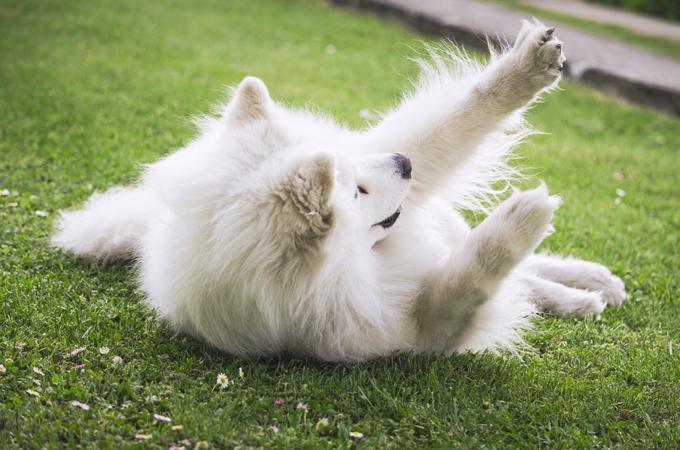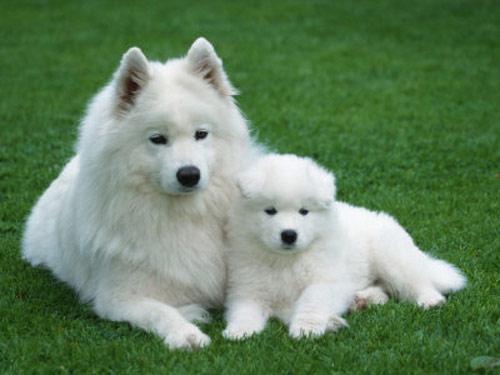The first image is the image on the left, the second image is the image on the right. For the images shown, is this caption "There are three dogs" true? Answer yes or no. Yes. The first image is the image on the left, the second image is the image on the right. For the images displayed, is the sentence "One of the images has exactly one dog." factually correct? Answer yes or no. Yes. 